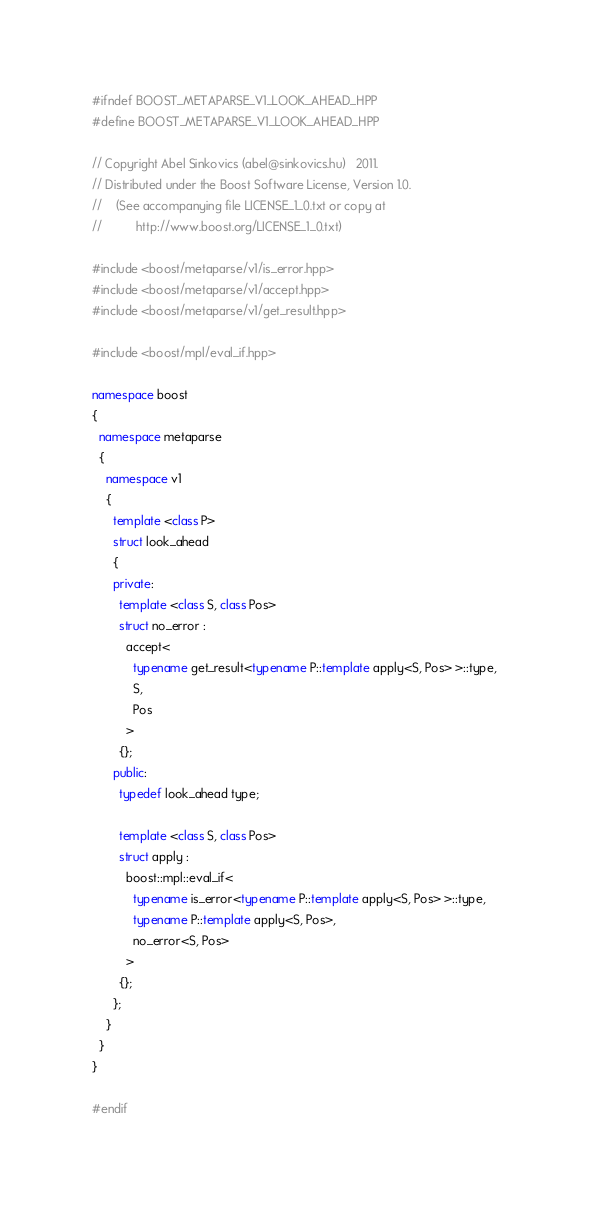<code> <loc_0><loc_0><loc_500><loc_500><_C++_>#ifndef BOOST_METAPARSE_V1_LOOK_AHEAD_HPP
#define BOOST_METAPARSE_V1_LOOK_AHEAD_HPP

// Copyright Abel Sinkovics (abel@sinkovics.hu)   2011.
// Distributed under the Boost Software License, Version 1.0.
//    (See accompanying file LICENSE_1_0.txt or copy at
//          http://www.boost.org/LICENSE_1_0.txt)

#include <boost/metaparse/v1/is_error.hpp>
#include <boost/metaparse/v1/accept.hpp>
#include <boost/metaparse/v1/get_result.hpp>

#include <boost/mpl/eval_if.hpp>

namespace boost
{
  namespace metaparse
  {
    namespace v1
    {
      template <class P>
      struct look_ahead
      {
      private:
        template <class S, class Pos>
        struct no_error :
          accept<
            typename get_result<typename P::template apply<S, Pos> >::type,
            S,
            Pos
          >
        {};
      public:
        typedef look_ahead type;
        
        template <class S, class Pos>
        struct apply :
          boost::mpl::eval_if<
            typename is_error<typename P::template apply<S, Pos> >::type,
            typename P::template apply<S, Pos>,
            no_error<S, Pos>
          >
        {};
      };
    }
  }
}

#endif

</code> 